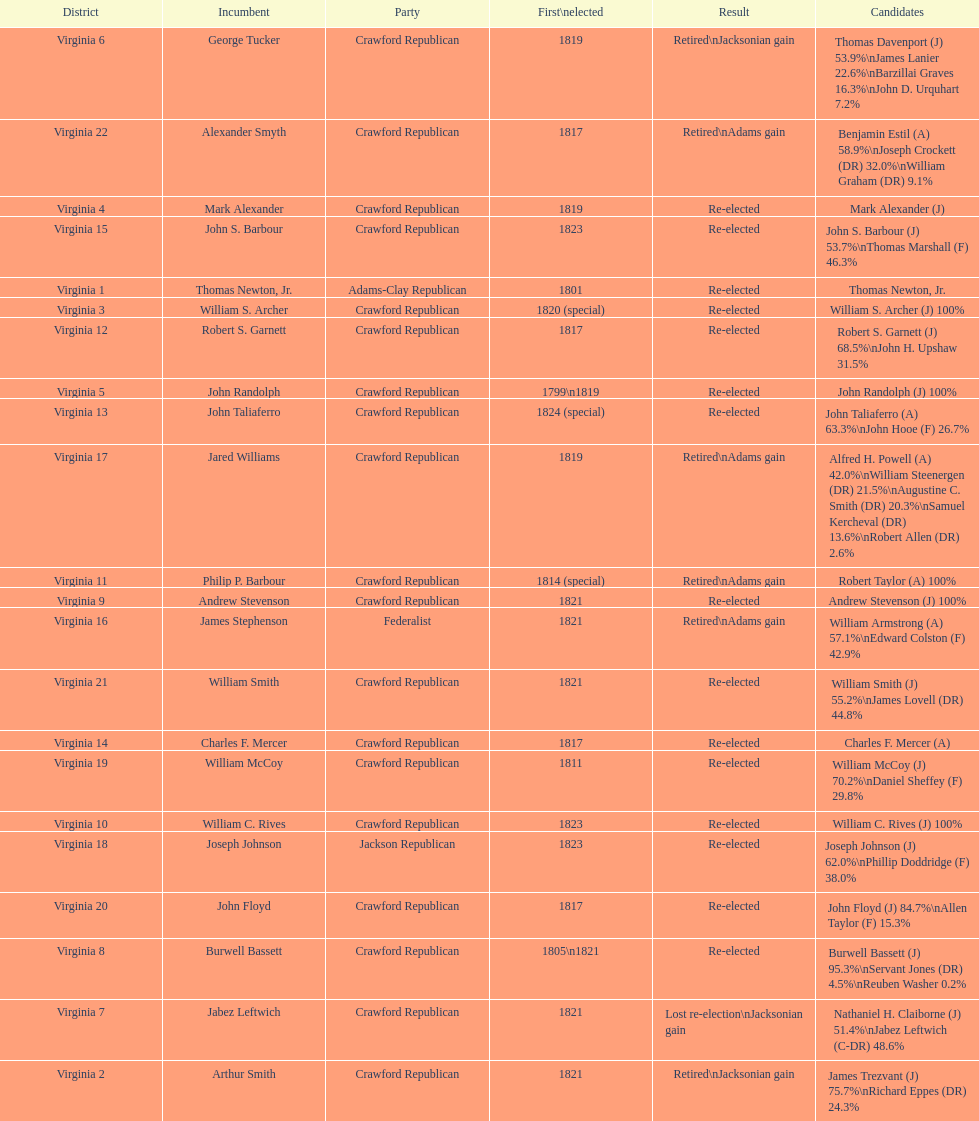Number of incumbents who retired or lost re-election 7. 